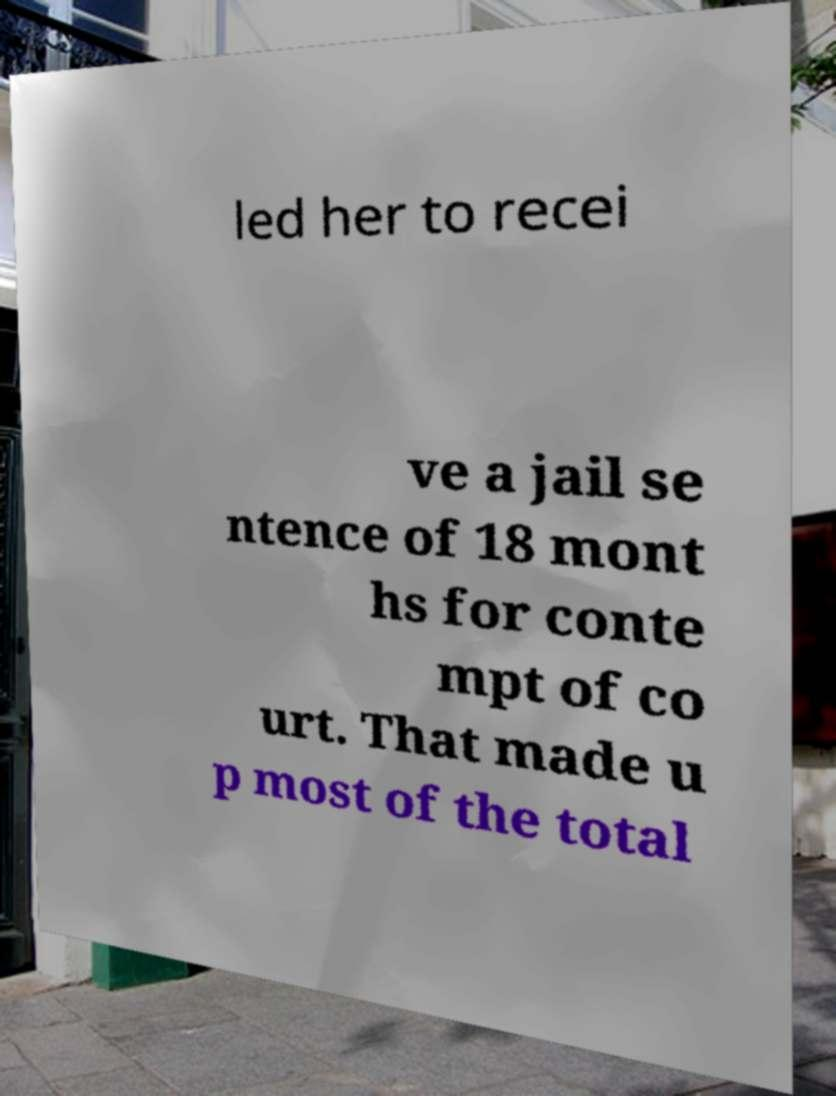What messages or text are displayed in this image? I need them in a readable, typed format. led her to recei ve a jail se ntence of 18 mont hs for conte mpt of co urt. That made u p most of the total 